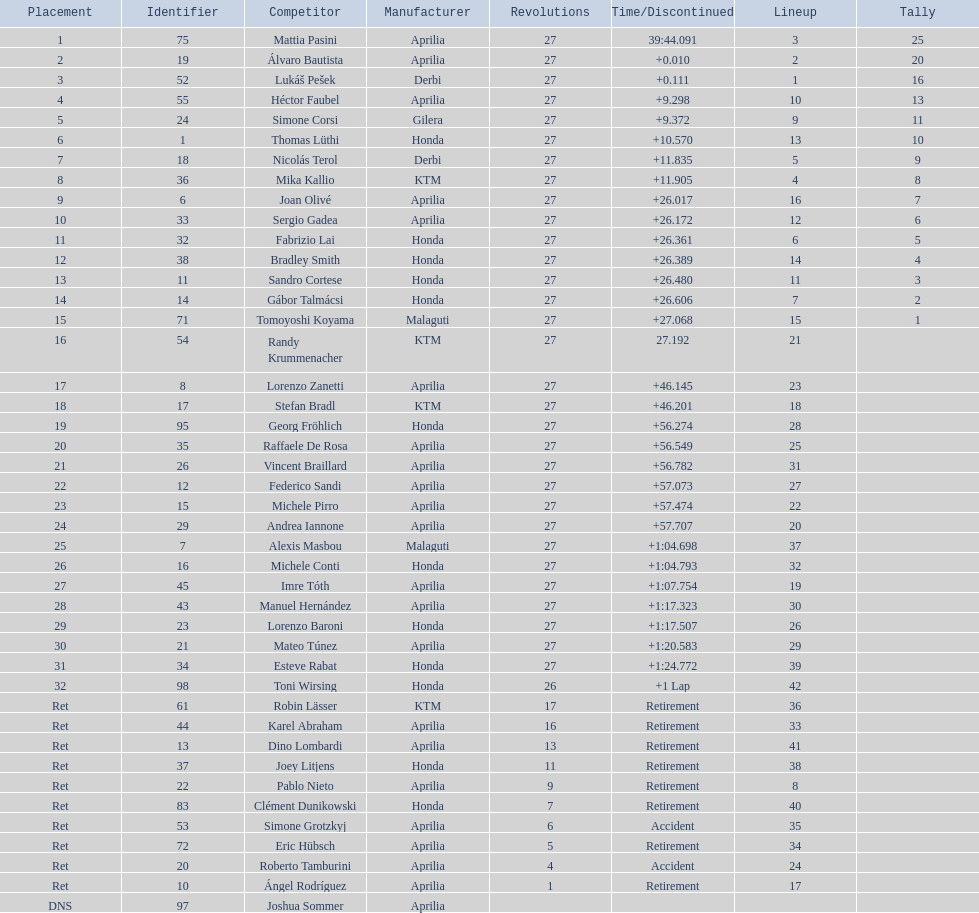Out of all the people who have points, who has the least? Tomoyoshi Koyama. 